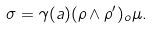<formula> <loc_0><loc_0><loc_500><loc_500>\sigma = \gamma ( a ) ( \rho \wedge \rho ^ { \prime } ) _ { o } \mu .</formula> 